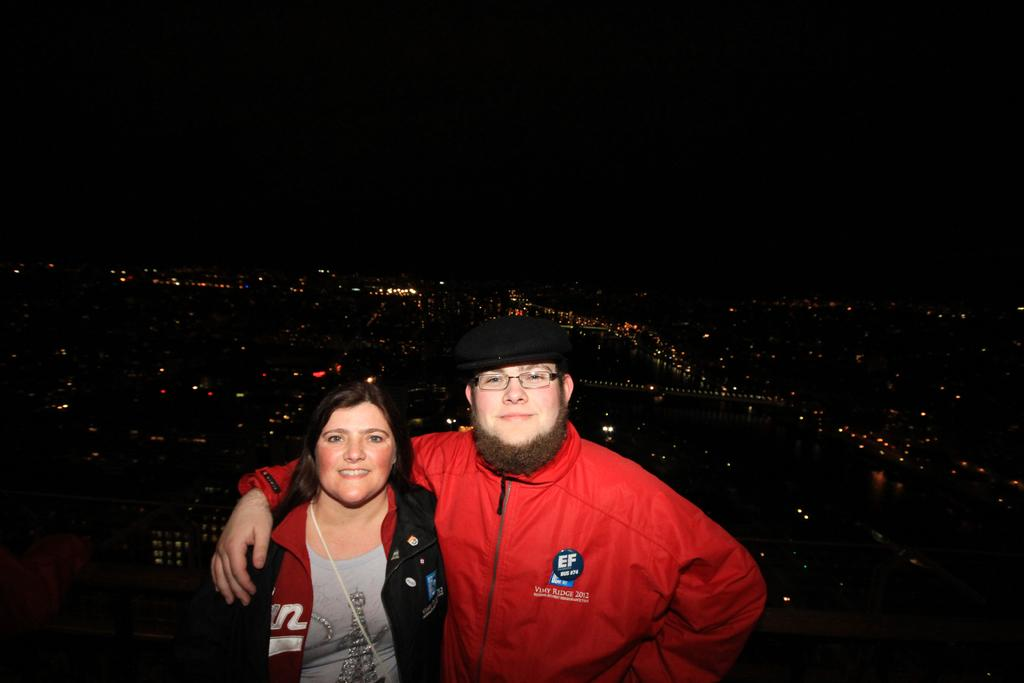How many people are in the image? There are two people in the image, a man and a woman. What is the man wearing in the image? The man is wearing glasses and a cap in the image. What is the color of the background in the image? The background of the image is dark. What can be seen in addition to the people in the image? There are lights visible in the image. What type of balls is the governor holding in the image? There is no governor present in the image, nor are there any balls visible. 